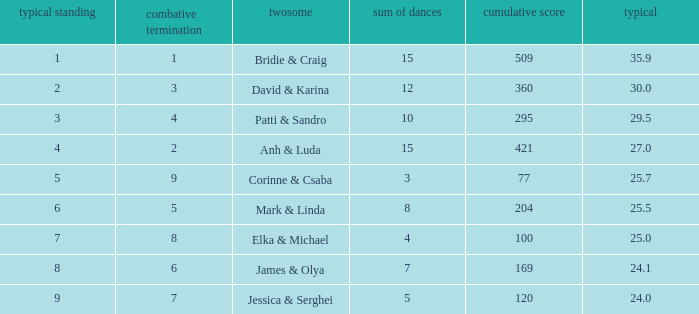Which couple has 295 as a total score? Patti & Sandro. 